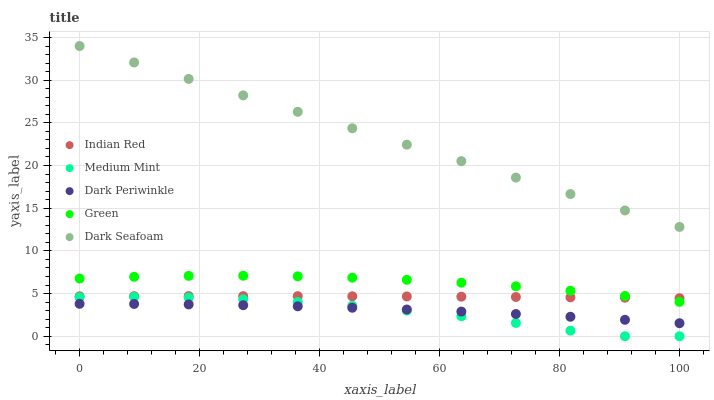Does Medium Mint have the minimum area under the curve?
Answer yes or no. Yes. Does Dark Seafoam have the maximum area under the curve?
Answer yes or no. Yes. Does Green have the minimum area under the curve?
Answer yes or no. No. Does Green have the maximum area under the curve?
Answer yes or no. No. Is Dark Seafoam the smoothest?
Answer yes or no. Yes. Is Medium Mint the roughest?
Answer yes or no. Yes. Is Green the smoothest?
Answer yes or no. No. Is Green the roughest?
Answer yes or no. No. Does Medium Mint have the lowest value?
Answer yes or no. Yes. Does Green have the lowest value?
Answer yes or no. No. Does Dark Seafoam have the highest value?
Answer yes or no. Yes. Does Green have the highest value?
Answer yes or no. No. Is Dark Periwinkle less than Dark Seafoam?
Answer yes or no. Yes. Is Dark Seafoam greater than Indian Red?
Answer yes or no. Yes. Does Green intersect Indian Red?
Answer yes or no. Yes. Is Green less than Indian Red?
Answer yes or no. No. Is Green greater than Indian Red?
Answer yes or no. No. Does Dark Periwinkle intersect Dark Seafoam?
Answer yes or no. No. 